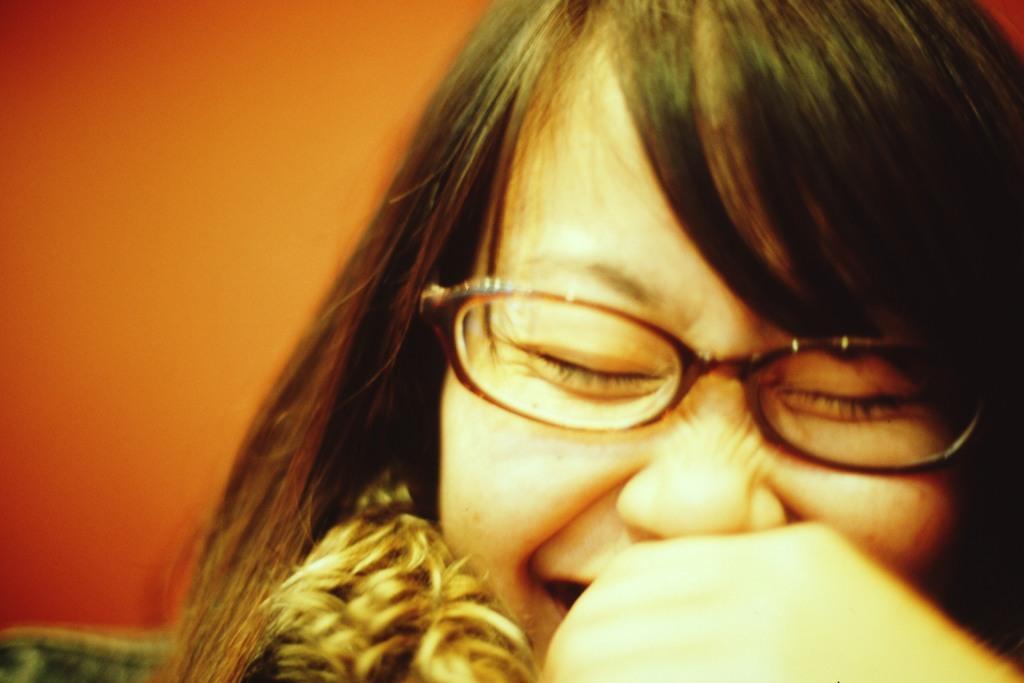How would you summarize this image in a sentence or two? In this image we can see a woman. 